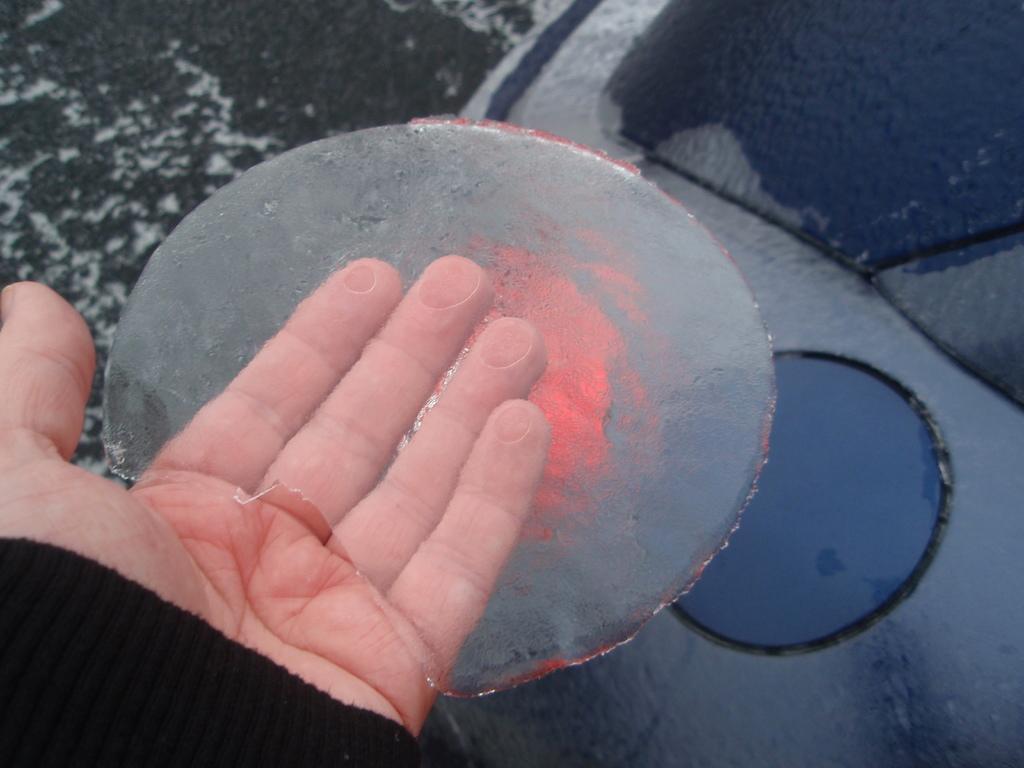Describe this image in one or two sentences. This image is taken outdoors. On the left side of the image there is a hand of a person holding ice. In the background it seems like a vehicle covered with snow. 